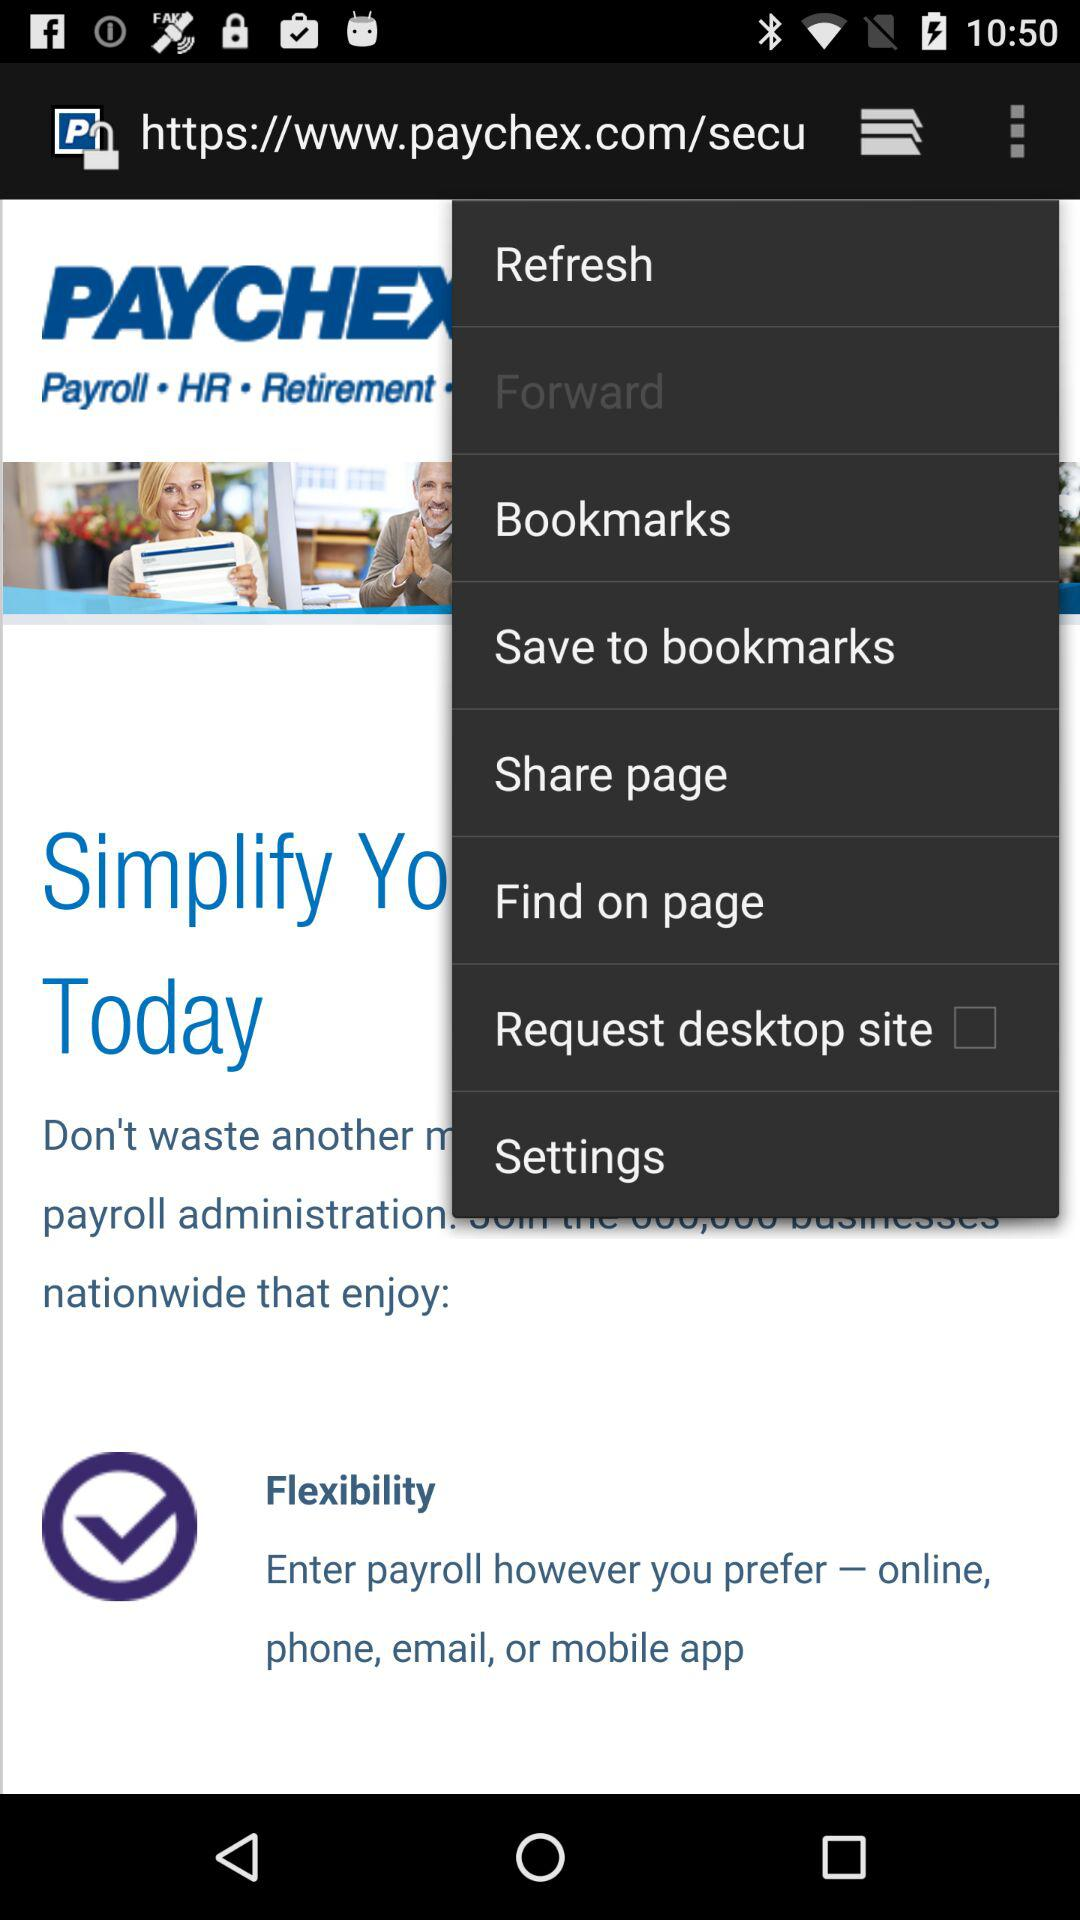Which tab is selected?
When the provided information is insufficient, respond with <no answer>. <no answer> 